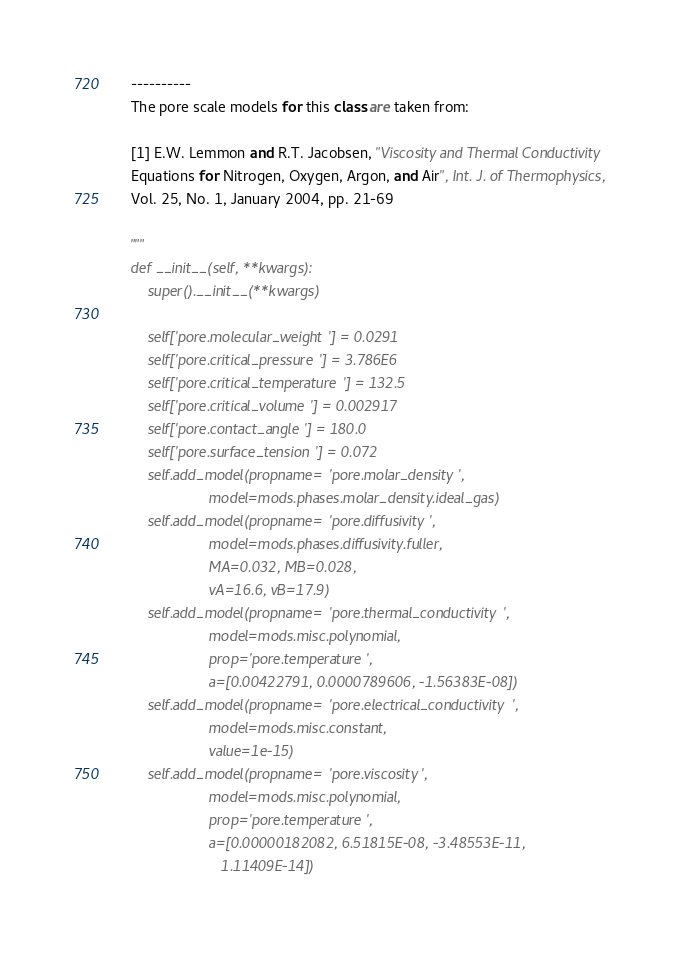Convert code to text. <code><loc_0><loc_0><loc_500><loc_500><_Python_>    ----------
    The pore scale models for this class are taken from:

    [1] E.W. Lemmon and R.T. Jacobsen, "Viscosity and Thermal Conductivity
    Equations for Nitrogen, Oxygen, Argon, and Air", Int. J. of Thermophysics,
    Vol. 25, No. 1, January 2004, pp. 21-69

    """
    def __init__(self, **kwargs):
        super().__init__(**kwargs)

        self['pore.molecular_weight'] = 0.0291
        self['pore.critical_pressure'] = 3.786E6
        self['pore.critical_temperature'] = 132.5
        self['pore.critical_volume'] = 0.002917
        self['pore.contact_angle'] = 180.0
        self['pore.surface_tension'] = 0.072
        self.add_model(propname='pore.molar_density',
                       model=mods.phases.molar_density.ideal_gas)
        self.add_model(propname='pore.diffusivity',
                       model=mods.phases.diffusivity.fuller,
                       MA=0.032, MB=0.028,
                       vA=16.6, vB=17.9)
        self.add_model(propname='pore.thermal_conductivity',
                       model=mods.misc.polynomial,
                       prop='pore.temperature',
                       a=[0.00422791, 0.0000789606, -1.56383E-08])
        self.add_model(propname='pore.electrical_conductivity',
                       model=mods.misc.constant,
                       value=1e-15)
        self.add_model(propname='pore.viscosity',
                       model=mods.misc.polynomial,
                       prop='pore.temperature',
                       a=[0.00000182082, 6.51815E-08, -3.48553E-11,
                          1.11409E-14])
</code> 